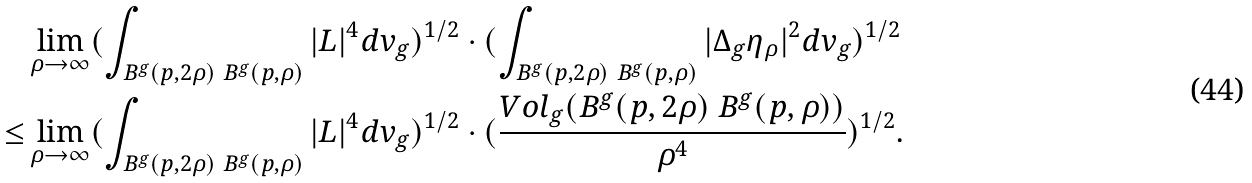Convert formula to latex. <formula><loc_0><loc_0><loc_500><loc_500>& \lim _ { \rho \rightarrow \infty } ( \int _ { B ^ { g } ( p , 2 \rho ) \ B ^ { g } ( p , \rho ) } | L | ^ { 4 } d v _ { g } ) ^ { 1 / 2 } \cdot ( \int _ { B ^ { g } ( p , 2 \rho ) \ B ^ { g } ( p , \rho ) } | \Delta _ { g } \eta _ { \rho } | ^ { 2 } d v _ { g } ) ^ { 1 / 2 } \\ \leq & \lim _ { \rho \rightarrow \infty } ( \int _ { B ^ { g } ( p , 2 \rho ) \ B ^ { g } ( p , \rho ) } | L | ^ { 4 } d v _ { g } ) ^ { 1 / 2 } \cdot ( \frac { V o l _ { g } ( B ^ { g } ( p , 2 \rho ) \ B ^ { g } ( p , \rho ) ) } { \rho ^ { 4 } } ) ^ { 1 / 2 } . \\</formula> 